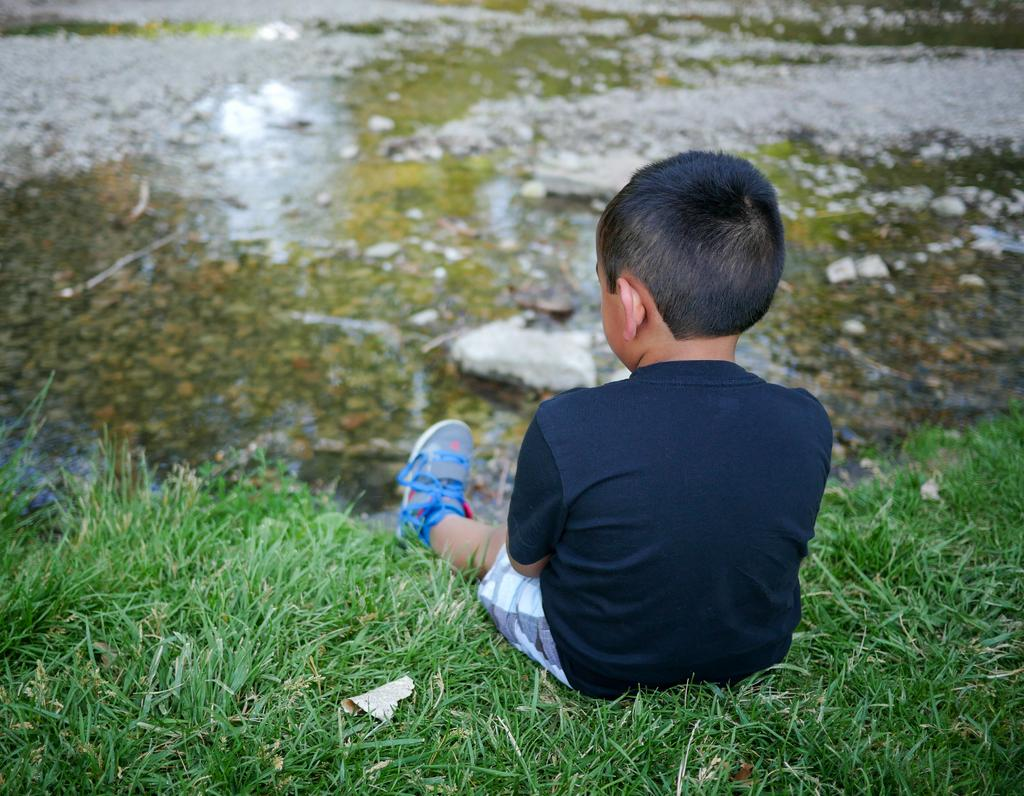What is the main subject of the image? The main subject of the image is a little boy. Where is the boy sitting in the image? The boy is sitting on the grass. What type of clothing is the boy wearing? The boy is wearing a t-shirt, shorts, and shoes. What can be seen in the middle of the image? There is water in the middle of the image. What type of iron can be seen in the image? There is no iron present in the image. What trail is visible in the image? There is no trail visible in the image. 